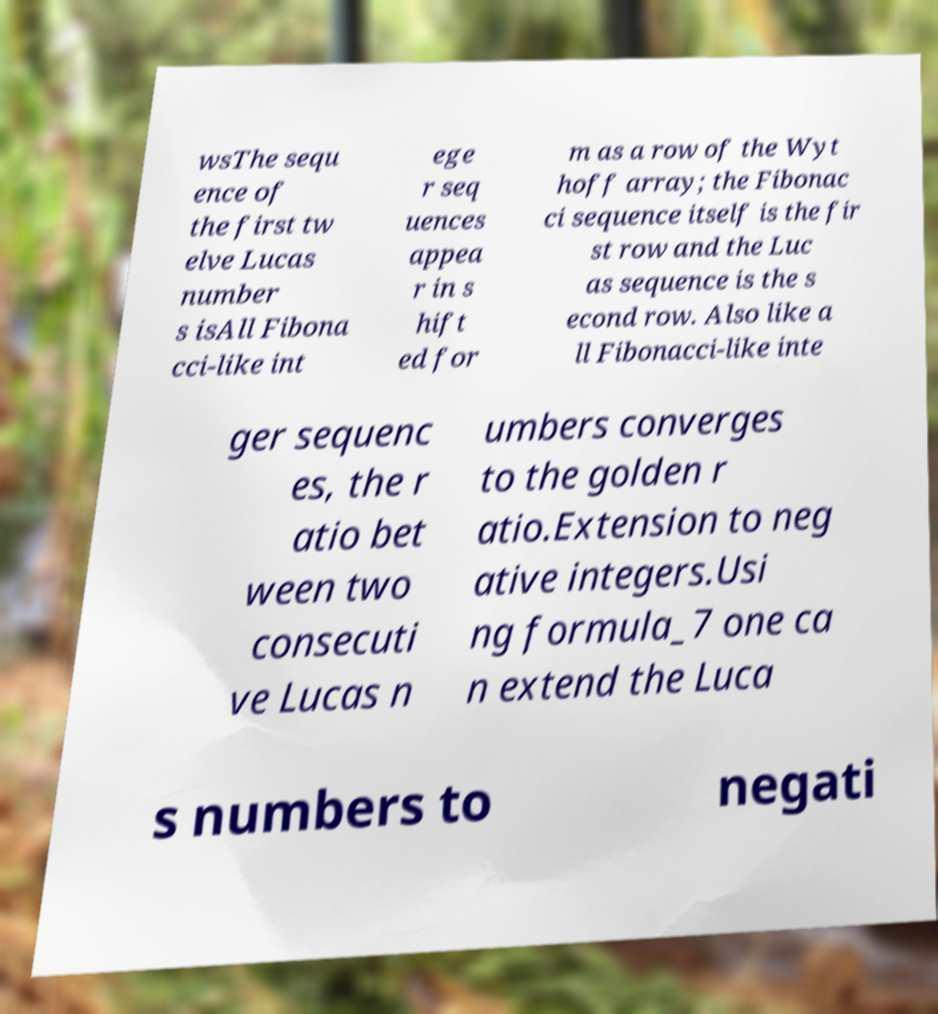Can you accurately transcribe the text from the provided image for me? wsThe sequ ence of the first tw elve Lucas number s isAll Fibona cci-like int ege r seq uences appea r in s hift ed for m as a row of the Wyt hoff array; the Fibonac ci sequence itself is the fir st row and the Luc as sequence is the s econd row. Also like a ll Fibonacci-like inte ger sequenc es, the r atio bet ween two consecuti ve Lucas n umbers converges to the golden r atio.Extension to neg ative integers.Usi ng formula_7 one ca n extend the Luca s numbers to negati 